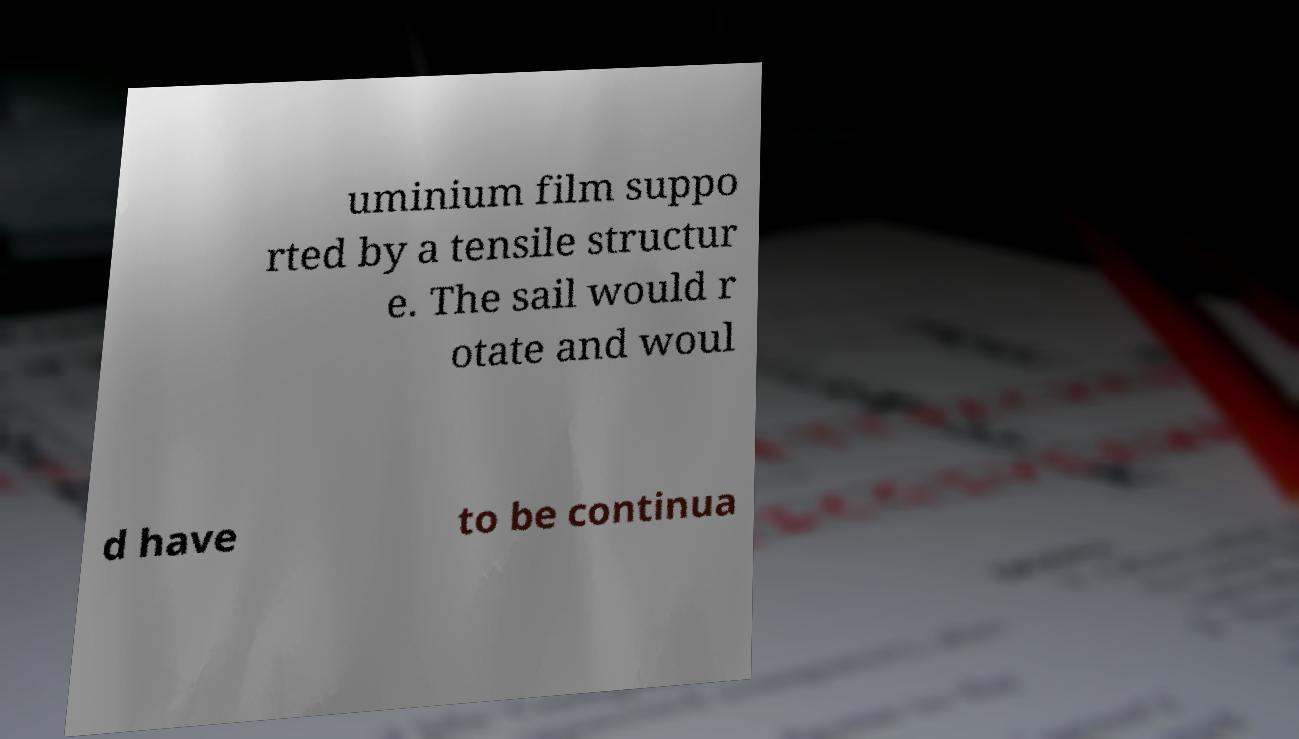I need the written content from this picture converted into text. Can you do that? uminium film suppo rted by a tensile structur e. The sail would r otate and woul d have to be continua 